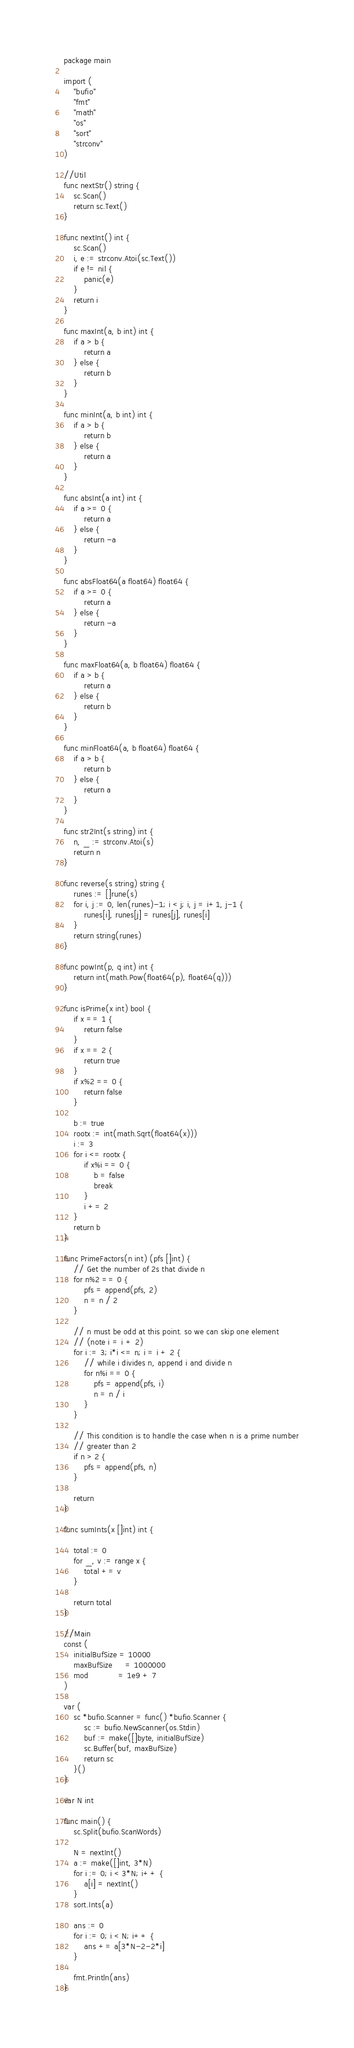Convert code to text. <code><loc_0><loc_0><loc_500><loc_500><_Go_>package main

import (
	"bufio"
	"fmt"
	"math"
	"os"
	"sort"
	"strconv"
)

//Util
func nextStr() string {
	sc.Scan()
	return sc.Text()
}

func nextInt() int {
	sc.Scan()
	i, e := strconv.Atoi(sc.Text())
	if e != nil {
		panic(e)
	}
	return i
}

func maxInt(a, b int) int {
	if a > b {
		return a
	} else {
		return b
	}
}

func minInt(a, b int) int {
	if a > b {
		return b
	} else {
		return a
	}
}

func absInt(a int) int {
	if a >= 0 {
		return a
	} else {
		return -a
	}
}

func absFloat64(a float64) float64 {
	if a >= 0 {
		return a
	} else {
		return -a
	}
}

func maxFloat64(a, b float64) float64 {
	if a > b {
		return a
	} else {
		return b
	}
}

func minFloat64(a, b float64) float64 {
	if a > b {
		return b
	} else {
		return a
	}
}

func str2Int(s string) int {
	n, _ := strconv.Atoi(s)
	return n
}

func reverse(s string) string {
	runes := []rune(s)
	for i, j := 0, len(runes)-1; i < j; i, j = i+1, j-1 {
		runes[i], runes[j] = runes[j], runes[i]
	}
	return string(runes)
}

func powInt(p, q int) int {
	return int(math.Pow(float64(p), float64(q)))
}

func isPrime(x int) bool {
	if x == 1 {
		return false
	}
	if x == 2 {
		return true
	}
	if x%2 == 0 {
		return false
	}

	b := true
	rootx := int(math.Sqrt(float64(x)))
	i := 3
	for i <= rootx {
		if x%i == 0 {
			b = false
			break
		}
		i += 2
	}
	return b
}

func PrimeFactors(n int) (pfs []int) {
	// Get the number of 2s that divide n
	for n%2 == 0 {
		pfs = append(pfs, 2)
		n = n / 2
	}

	// n must be odd at this point. so we can skip one element
	// (note i = i + 2)
	for i := 3; i*i <= n; i = i + 2 {
		// while i divides n, append i and divide n
		for n%i == 0 {
			pfs = append(pfs, i)
			n = n / i
		}
	}

	// This condition is to handle the case when n is a prime number
	// greater than 2
	if n > 2 {
		pfs = append(pfs, n)
	}

	return
}

func sumInts(x []int) int {

	total := 0
	for _, v := range x {
		total += v
	}

	return total
}

//Main
const (
	initialBufSize = 10000
	maxBufSize     = 1000000
	mod            = 1e9 + 7
)

var (
	sc *bufio.Scanner = func() *bufio.Scanner {
		sc := bufio.NewScanner(os.Stdin)
		buf := make([]byte, initialBufSize)
		sc.Buffer(buf, maxBufSize)
		return sc
	}()
)

var N int

func main() {
	sc.Split(bufio.ScanWords)

	N = nextInt()
	a := make([]int, 3*N)
	for i := 0; i < 3*N; i++ {
		a[i] = nextInt()
	}
	sort.Ints(a)

	ans := 0
	for i := 0; i < N; i++ {
		ans += a[3*N-2-2*i]
	}

	fmt.Println(ans)
}
</code> 